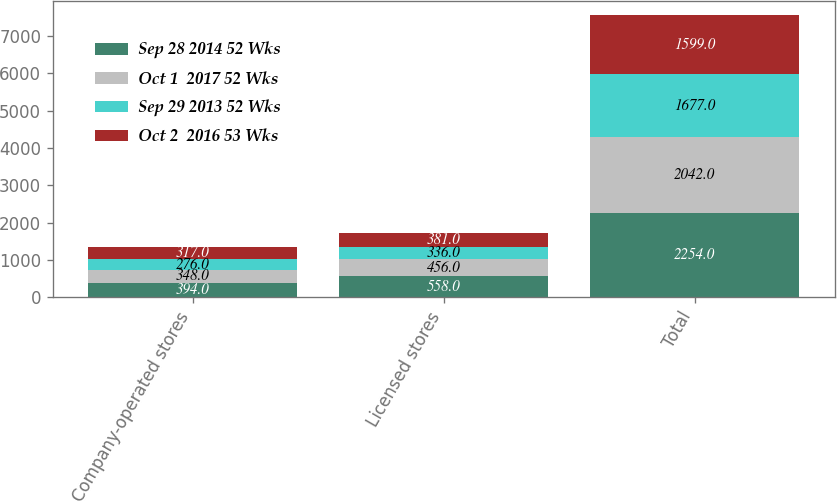<chart> <loc_0><loc_0><loc_500><loc_500><stacked_bar_chart><ecel><fcel>Company-operated stores<fcel>Licensed stores<fcel>Total<nl><fcel>Sep 28 2014 52 Wks<fcel>394<fcel>558<fcel>2254<nl><fcel>Oct 1  2017 52 Wks<fcel>348<fcel>456<fcel>2042<nl><fcel>Sep 29 2013 52 Wks<fcel>276<fcel>336<fcel>1677<nl><fcel>Oct 2  2016 53 Wks<fcel>317<fcel>381<fcel>1599<nl></chart> 